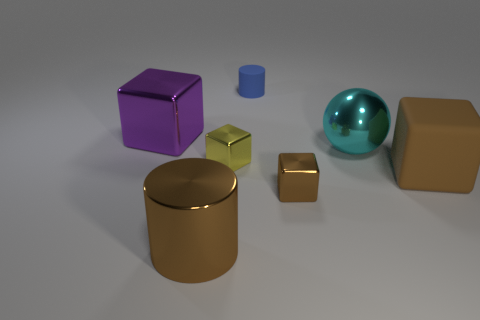Subtract all gray cylinders. How many brown cubes are left? 2 Subtract all purple cubes. How many cubes are left? 3 Subtract 2 cubes. How many cubes are left? 2 Subtract all tiny yellow metal blocks. How many blocks are left? 3 Subtract all red cubes. Subtract all purple cylinders. How many cubes are left? 4 Add 1 large brown cubes. How many objects exist? 8 Subtract all spheres. How many objects are left? 6 Subtract all large gray objects. Subtract all yellow objects. How many objects are left? 6 Add 6 purple cubes. How many purple cubes are left? 7 Add 2 large blocks. How many large blocks exist? 4 